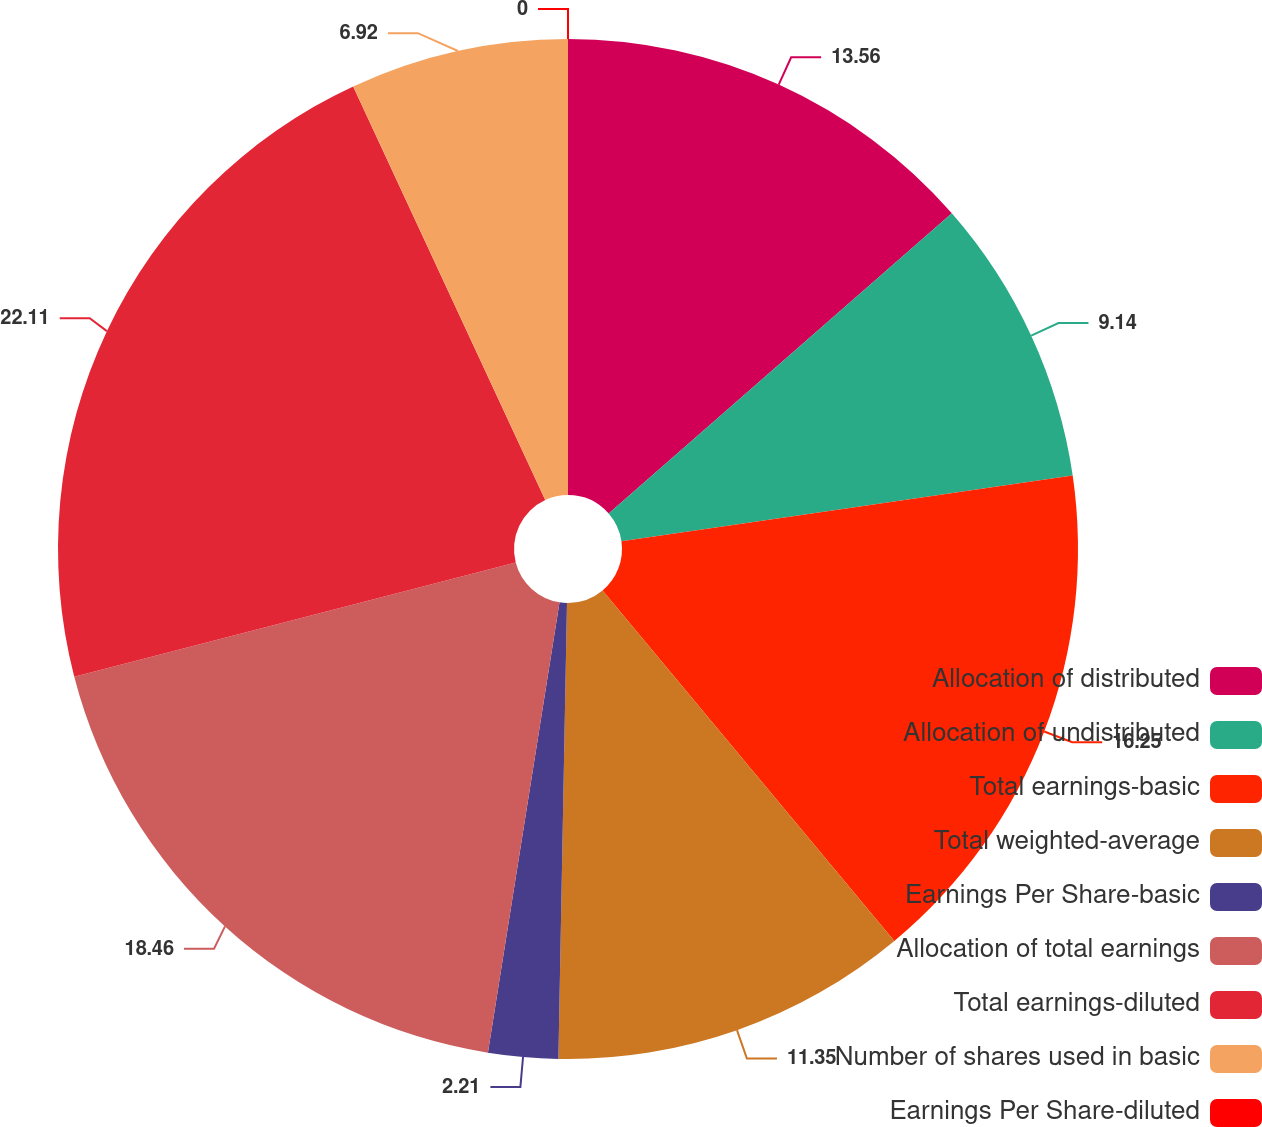<chart> <loc_0><loc_0><loc_500><loc_500><pie_chart><fcel>Allocation of distributed<fcel>Allocation of undistributed<fcel>Total earnings-basic<fcel>Total weighted-average<fcel>Earnings Per Share-basic<fcel>Allocation of total earnings<fcel>Total earnings-diluted<fcel>Number of shares used in basic<fcel>Earnings Per Share-diluted<nl><fcel>13.56%<fcel>9.14%<fcel>16.25%<fcel>11.35%<fcel>2.21%<fcel>18.46%<fcel>22.11%<fcel>6.92%<fcel>0.0%<nl></chart> 